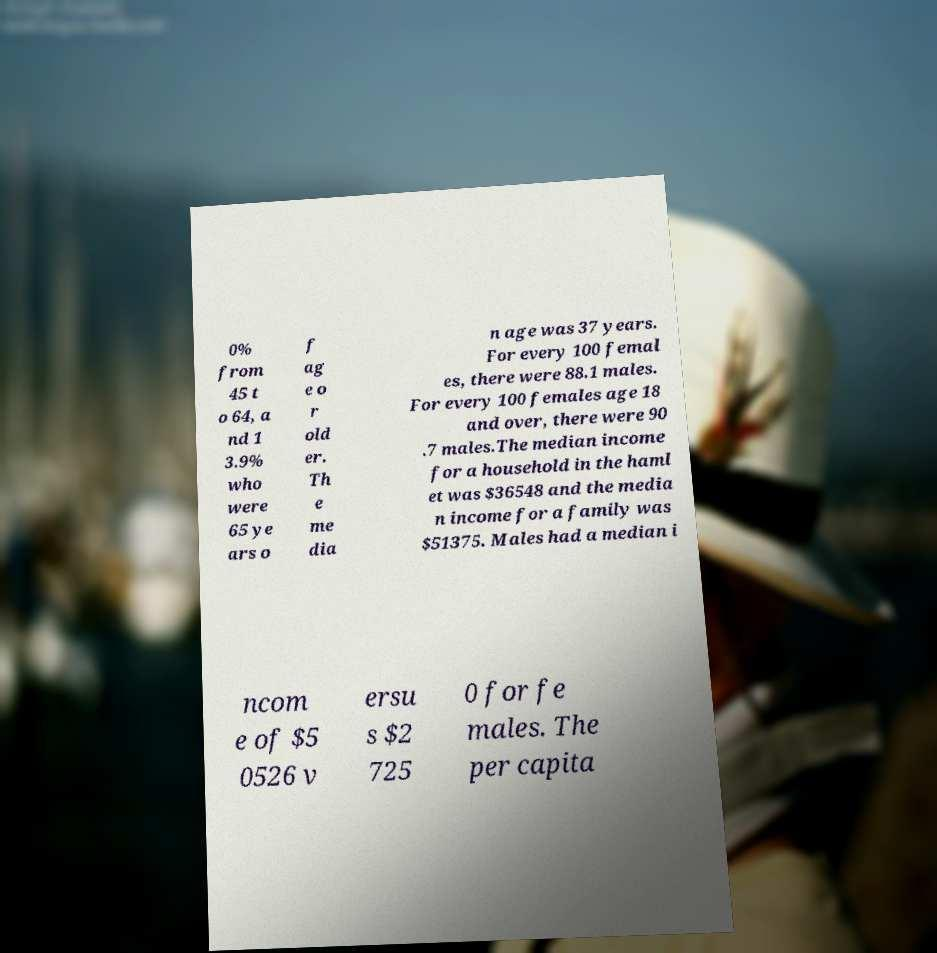Please identify and transcribe the text found in this image. 0% from 45 t o 64, a nd 1 3.9% who were 65 ye ars o f ag e o r old er. Th e me dia n age was 37 years. For every 100 femal es, there were 88.1 males. For every 100 females age 18 and over, there were 90 .7 males.The median income for a household in the haml et was $36548 and the media n income for a family was $51375. Males had a median i ncom e of $5 0526 v ersu s $2 725 0 for fe males. The per capita 